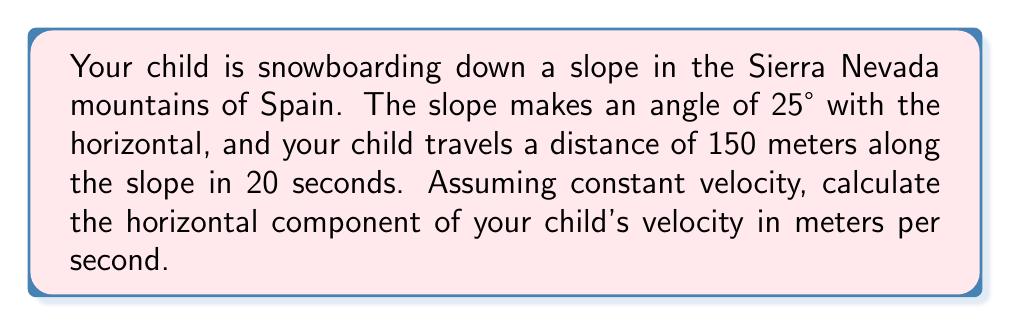Solve this math problem. Let's approach this step-by-step:

1) First, we need to understand what we're given:
   - Angle of the slope: $\theta = 25°$
   - Distance along the slope: $s = 150$ m
   - Time taken: $t = 20$ s

2) We can calculate the velocity along the slope:
   $v_{slope} = \frac{s}{t} = \frac{150 \text{ m}}{20 \text{ s}} = 7.5 \text{ m/s}$

3) Now, we need to find the horizontal component of this velocity. We can use trigonometry for this.

4) The horizontal component of velocity ($v_x$) is related to the velocity along the slope ($v_{slope}$) by the cosine of the angle:

   $v_x = v_{slope} \cos(\theta)$

5) Substituting our values:

   $v_x = 7.5 \text{ m/s} \cdot \cos(25°)$

6) Using a calculator or trigonometric table:

   $v_x = 7.5 \text{ m/s} \cdot 0.9063$

7) Calculating:

   $v_x = 6.80 \text{ m/s}$

Thus, the horizontal component of your child's velocity is approximately 6.80 m/s.
Answer: $6.80 \text{ m/s}$ 